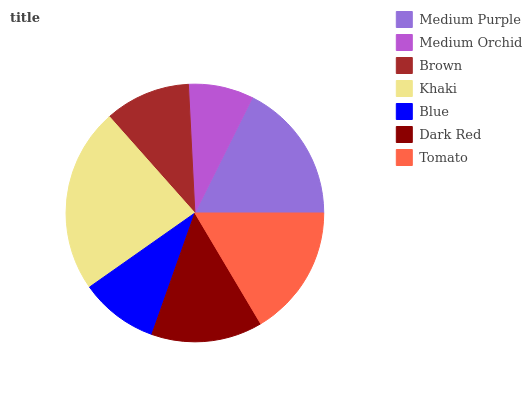Is Medium Orchid the minimum?
Answer yes or no. Yes. Is Khaki the maximum?
Answer yes or no. Yes. Is Brown the minimum?
Answer yes or no. No. Is Brown the maximum?
Answer yes or no. No. Is Brown greater than Medium Orchid?
Answer yes or no. Yes. Is Medium Orchid less than Brown?
Answer yes or no. Yes. Is Medium Orchid greater than Brown?
Answer yes or no. No. Is Brown less than Medium Orchid?
Answer yes or no. No. Is Dark Red the high median?
Answer yes or no. Yes. Is Dark Red the low median?
Answer yes or no. Yes. Is Blue the high median?
Answer yes or no. No. Is Brown the low median?
Answer yes or no. No. 